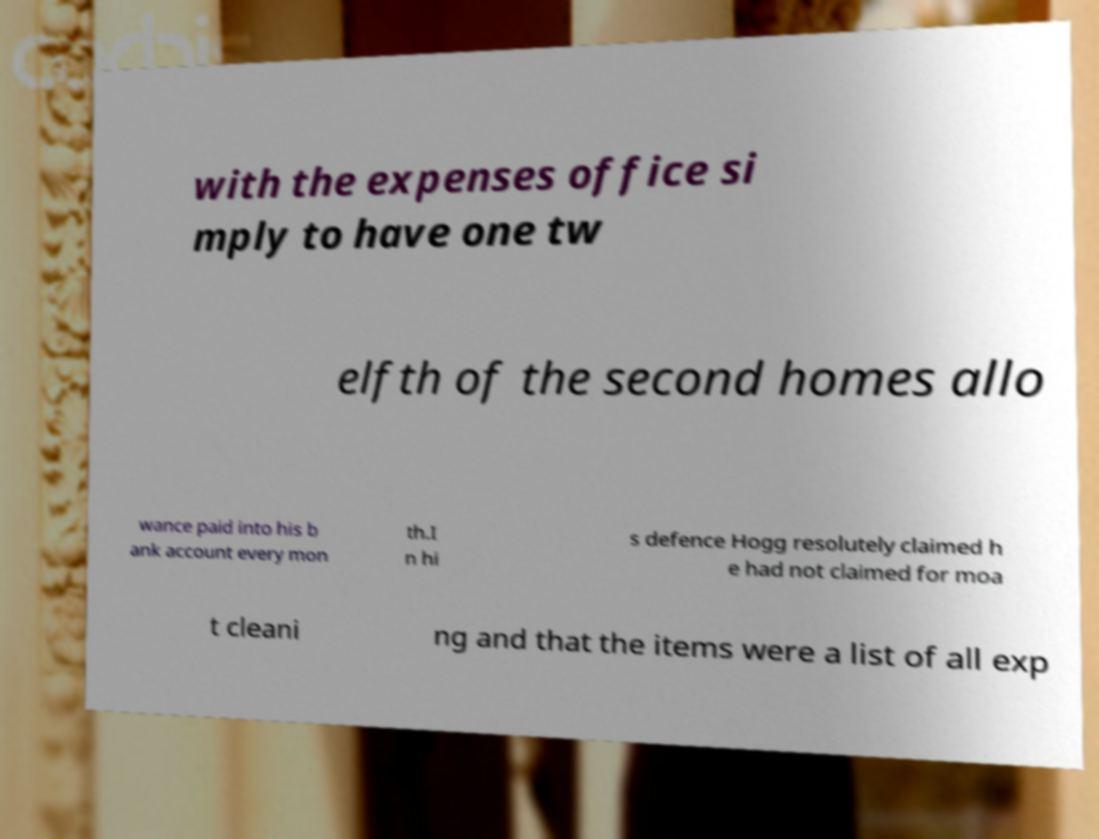There's text embedded in this image that I need extracted. Can you transcribe it verbatim? with the expenses office si mply to have one tw elfth of the second homes allo wance paid into his b ank account every mon th.I n hi s defence Hogg resolutely claimed h e had not claimed for moa t cleani ng and that the items were a list of all exp 